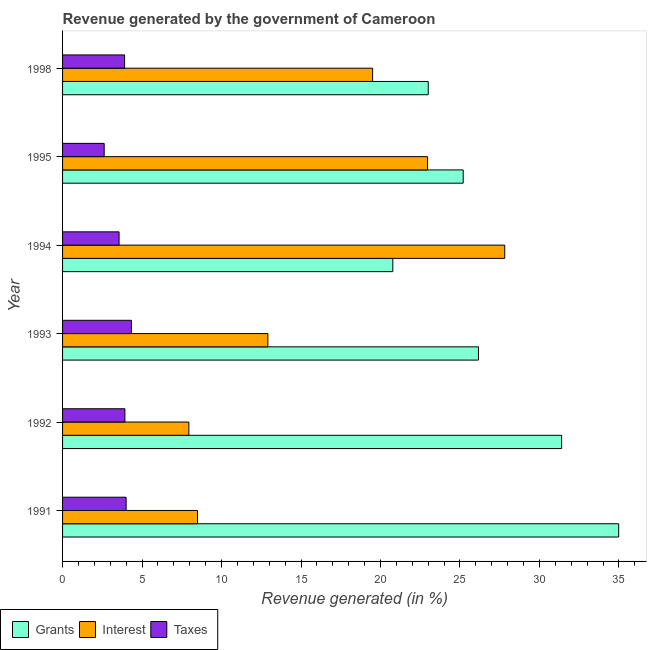How many bars are there on the 1st tick from the bottom?
Make the answer very short. 3. In how many cases, is the number of bars for a given year not equal to the number of legend labels?
Keep it short and to the point. 0. What is the percentage of revenue generated by taxes in 1991?
Provide a succinct answer. 4. Across all years, what is the maximum percentage of revenue generated by grants?
Your response must be concise. 34.99. Across all years, what is the minimum percentage of revenue generated by taxes?
Make the answer very short. 2.62. In which year was the percentage of revenue generated by interest maximum?
Offer a terse response. 1994. In which year was the percentage of revenue generated by taxes minimum?
Make the answer very short. 1995. What is the total percentage of revenue generated by grants in the graph?
Make the answer very short. 161.53. What is the difference between the percentage of revenue generated by grants in 1993 and that in 1994?
Your answer should be very brief. 5.39. What is the difference between the percentage of revenue generated by taxes in 1995 and the percentage of revenue generated by grants in 1993?
Keep it short and to the point. -23.55. What is the average percentage of revenue generated by interest per year?
Your response must be concise. 16.61. In the year 1998, what is the difference between the percentage of revenue generated by grants and percentage of revenue generated by taxes?
Provide a short and direct response. 19.1. In how many years, is the percentage of revenue generated by taxes greater than 12 %?
Keep it short and to the point. 0. What is the ratio of the percentage of revenue generated by grants in 1995 to that in 1998?
Your response must be concise. 1.1. Is the difference between the percentage of revenue generated by grants in 1991 and 1994 greater than the difference between the percentage of revenue generated by taxes in 1991 and 1994?
Make the answer very short. Yes. What is the difference between the highest and the second highest percentage of revenue generated by interest?
Offer a terse response. 4.86. What is the difference between the highest and the lowest percentage of revenue generated by taxes?
Ensure brevity in your answer.  1.71. What does the 3rd bar from the top in 1992 represents?
Offer a terse response. Grants. What does the 3rd bar from the bottom in 1991 represents?
Your answer should be very brief. Taxes. Is it the case that in every year, the sum of the percentage of revenue generated by grants and percentage of revenue generated by interest is greater than the percentage of revenue generated by taxes?
Your answer should be compact. Yes. Are all the bars in the graph horizontal?
Provide a short and direct response. Yes. Does the graph contain any zero values?
Offer a terse response. No. Does the graph contain grids?
Give a very brief answer. No. Where does the legend appear in the graph?
Your answer should be compact. Bottom left. How many legend labels are there?
Your answer should be very brief. 3. What is the title of the graph?
Keep it short and to the point. Revenue generated by the government of Cameroon. Does "Consumption Tax" appear as one of the legend labels in the graph?
Keep it short and to the point. No. What is the label or title of the X-axis?
Ensure brevity in your answer.  Revenue generated (in %). What is the label or title of the Y-axis?
Give a very brief answer. Year. What is the Revenue generated (in %) in Grants in 1991?
Your answer should be very brief. 34.99. What is the Revenue generated (in %) in Interest in 1991?
Ensure brevity in your answer.  8.49. What is the Revenue generated (in %) in Taxes in 1991?
Give a very brief answer. 4. What is the Revenue generated (in %) in Grants in 1992?
Offer a terse response. 31.4. What is the Revenue generated (in %) of Interest in 1992?
Make the answer very short. 7.94. What is the Revenue generated (in %) of Taxes in 1992?
Your answer should be compact. 3.92. What is the Revenue generated (in %) in Grants in 1993?
Provide a short and direct response. 26.16. What is the Revenue generated (in %) of Interest in 1993?
Keep it short and to the point. 12.92. What is the Revenue generated (in %) in Taxes in 1993?
Your response must be concise. 4.33. What is the Revenue generated (in %) of Grants in 1994?
Keep it short and to the point. 20.78. What is the Revenue generated (in %) of Interest in 1994?
Ensure brevity in your answer.  27.82. What is the Revenue generated (in %) of Taxes in 1994?
Give a very brief answer. 3.56. What is the Revenue generated (in %) of Grants in 1995?
Give a very brief answer. 25.2. What is the Revenue generated (in %) of Interest in 1995?
Your answer should be compact. 22.96. What is the Revenue generated (in %) of Taxes in 1995?
Offer a very short reply. 2.62. What is the Revenue generated (in %) in Grants in 1998?
Offer a terse response. 23.01. What is the Revenue generated (in %) in Interest in 1998?
Your answer should be compact. 19.51. What is the Revenue generated (in %) in Taxes in 1998?
Your response must be concise. 3.9. Across all years, what is the maximum Revenue generated (in %) in Grants?
Ensure brevity in your answer.  34.99. Across all years, what is the maximum Revenue generated (in %) in Interest?
Make the answer very short. 27.82. Across all years, what is the maximum Revenue generated (in %) of Taxes?
Offer a terse response. 4.33. Across all years, what is the minimum Revenue generated (in %) in Grants?
Offer a terse response. 20.78. Across all years, what is the minimum Revenue generated (in %) of Interest?
Provide a short and direct response. 7.94. Across all years, what is the minimum Revenue generated (in %) of Taxes?
Provide a succinct answer. 2.62. What is the total Revenue generated (in %) of Grants in the graph?
Make the answer very short. 161.53. What is the total Revenue generated (in %) in Interest in the graph?
Your answer should be compact. 99.63. What is the total Revenue generated (in %) of Taxes in the graph?
Your answer should be compact. 22.33. What is the difference between the Revenue generated (in %) of Grants in 1991 and that in 1992?
Your answer should be compact. 3.59. What is the difference between the Revenue generated (in %) of Interest in 1991 and that in 1992?
Give a very brief answer. 0.54. What is the difference between the Revenue generated (in %) in Taxes in 1991 and that in 1992?
Your answer should be compact. 0.08. What is the difference between the Revenue generated (in %) of Grants in 1991 and that in 1993?
Ensure brevity in your answer.  8.82. What is the difference between the Revenue generated (in %) in Interest in 1991 and that in 1993?
Offer a terse response. -4.43. What is the difference between the Revenue generated (in %) in Taxes in 1991 and that in 1993?
Provide a short and direct response. -0.33. What is the difference between the Revenue generated (in %) of Grants in 1991 and that in 1994?
Offer a very short reply. 14.21. What is the difference between the Revenue generated (in %) of Interest in 1991 and that in 1994?
Provide a succinct answer. -19.33. What is the difference between the Revenue generated (in %) of Taxes in 1991 and that in 1994?
Provide a short and direct response. 0.44. What is the difference between the Revenue generated (in %) in Grants in 1991 and that in 1995?
Give a very brief answer. 9.78. What is the difference between the Revenue generated (in %) in Interest in 1991 and that in 1995?
Your answer should be compact. -14.47. What is the difference between the Revenue generated (in %) in Taxes in 1991 and that in 1995?
Your answer should be very brief. 1.38. What is the difference between the Revenue generated (in %) of Grants in 1991 and that in 1998?
Offer a terse response. 11.98. What is the difference between the Revenue generated (in %) of Interest in 1991 and that in 1998?
Provide a succinct answer. -11.02. What is the difference between the Revenue generated (in %) in Taxes in 1991 and that in 1998?
Give a very brief answer. 0.1. What is the difference between the Revenue generated (in %) of Grants in 1992 and that in 1993?
Offer a very short reply. 5.23. What is the difference between the Revenue generated (in %) in Interest in 1992 and that in 1993?
Make the answer very short. -4.97. What is the difference between the Revenue generated (in %) in Taxes in 1992 and that in 1993?
Your answer should be very brief. -0.41. What is the difference between the Revenue generated (in %) in Grants in 1992 and that in 1994?
Keep it short and to the point. 10.62. What is the difference between the Revenue generated (in %) in Interest in 1992 and that in 1994?
Provide a short and direct response. -19.87. What is the difference between the Revenue generated (in %) of Taxes in 1992 and that in 1994?
Your answer should be very brief. 0.37. What is the difference between the Revenue generated (in %) in Grants in 1992 and that in 1995?
Give a very brief answer. 6.19. What is the difference between the Revenue generated (in %) of Interest in 1992 and that in 1995?
Give a very brief answer. -15.02. What is the difference between the Revenue generated (in %) in Taxes in 1992 and that in 1995?
Your answer should be compact. 1.3. What is the difference between the Revenue generated (in %) of Grants in 1992 and that in 1998?
Provide a short and direct response. 8.39. What is the difference between the Revenue generated (in %) of Interest in 1992 and that in 1998?
Make the answer very short. -11.56. What is the difference between the Revenue generated (in %) in Taxes in 1992 and that in 1998?
Offer a terse response. 0.02. What is the difference between the Revenue generated (in %) of Grants in 1993 and that in 1994?
Ensure brevity in your answer.  5.39. What is the difference between the Revenue generated (in %) in Interest in 1993 and that in 1994?
Your answer should be very brief. -14.9. What is the difference between the Revenue generated (in %) of Taxes in 1993 and that in 1994?
Your answer should be compact. 0.77. What is the difference between the Revenue generated (in %) of Grants in 1993 and that in 1995?
Keep it short and to the point. 0.96. What is the difference between the Revenue generated (in %) of Interest in 1993 and that in 1995?
Your answer should be very brief. -10.05. What is the difference between the Revenue generated (in %) in Taxes in 1993 and that in 1995?
Give a very brief answer. 1.71. What is the difference between the Revenue generated (in %) in Grants in 1993 and that in 1998?
Make the answer very short. 3.16. What is the difference between the Revenue generated (in %) in Interest in 1993 and that in 1998?
Your response must be concise. -6.59. What is the difference between the Revenue generated (in %) in Taxes in 1993 and that in 1998?
Ensure brevity in your answer.  0.43. What is the difference between the Revenue generated (in %) in Grants in 1994 and that in 1995?
Provide a short and direct response. -4.43. What is the difference between the Revenue generated (in %) of Interest in 1994 and that in 1995?
Offer a very short reply. 4.86. What is the difference between the Revenue generated (in %) in Taxes in 1994 and that in 1995?
Give a very brief answer. 0.94. What is the difference between the Revenue generated (in %) in Grants in 1994 and that in 1998?
Offer a terse response. -2.23. What is the difference between the Revenue generated (in %) in Interest in 1994 and that in 1998?
Offer a terse response. 8.31. What is the difference between the Revenue generated (in %) of Taxes in 1994 and that in 1998?
Make the answer very short. -0.35. What is the difference between the Revenue generated (in %) of Grants in 1995 and that in 1998?
Offer a terse response. 2.2. What is the difference between the Revenue generated (in %) in Interest in 1995 and that in 1998?
Ensure brevity in your answer.  3.46. What is the difference between the Revenue generated (in %) of Taxes in 1995 and that in 1998?
Offer a terse response. -1.28. What is the difference between the Revenue generated (in %) in Grants in 1991 and the Revenue generated (in %) in Interest in 1992?
Your answer should be very brief. 27.04. What is the difference between the Revenue generated (in %) of Grants in 1991 and the Revenue generated (in %) of Taxes in 1992?
Keep it short and to the point. 31.06. What is the difference between the Revenue generated (in %) in Interest in 1991 and the Revenue generated (in %) in Taxes in 1992?
Your answer should be compact. 4.57. What is the difference between the Revenue generated (in %) in Grants in 1991 and the Revenue generated (in %) in Interest in 1993?
Ensure brevity in your answer.  22.07. What is the difference between the Revenue generated (in %) in Grants in 1991 and the Revenue generated (in %) in Taxes in 1993?
Keep it short and to the point. 30.66. What is the difference between the Revenue generated (in %) of Interest in 1991 and the Revenue generated (in %) of Taxes in 1993?
Your response must be concise. 4.16. What is the difference between the Revenue generated (in %) of Grants in 1991 and the Revenue generated (in %) of Interest in 1994?
Offer a terse response. 7.17. What is the difference between the Revenue generated (in %) of Grants in 1991 and the Revenue generated (in %) of Taxes in 1994?
Offer a very short reply. 31.43. What is the difference between the Revenue generated (in %) of Interest in 1991 and the Revenue generated (in %) of Taxes in 1994?
Provide a short and direct response. 4.93. What is the difference between the Revenue generated (in %) in Grants in 1991 and the Revenue generated (in %) in Interest in 1995?
Make the answer very short. 12.02. What is the difference between the Revenue generated (in %) of Grants in 1991 and the Revenue generated (in %) of Taxes in 1995?
Provide a succinct answer. 32.37. What is the difference between the Revenue generated (in %) in Interest in 1991 and the Revenue generated (in %) in Taxes in 1995?
Ensure brevity in your answer.  5.87. What is the difference between the Revenue generated (in %) in Grants in 1991 and the Revenue generated (in %) in Interest in 1998?
Give a very brief answer. 15.48. What is the difference between the Revenue generated (in %) of Grants in 1991 and the Revenue generated (in %) of Taxes in 1998?
Your answer should be very brief. 31.08. What is the difference between the Revenue generated (in %) in Interest in 1991 and the Revenue generated (in %) in Taxes in 1998?
Give a very brief answer. 4.59. What is the difference between the Revenue generated (in %) of Grants in 1992 and the Revenue generated (in %) of Interest in 1993?
Ensure brevity in your answer.  18.48. What is the difference between the Revenue generated (in %) of Grants in 1992 and the Revenue generated (in %) of Taxes in 1993?
Your response must be concise. 27.07. What is the difference between the Revenue generated (in %) in Interest in 1992 and the Revenue generated (in %) in Taxes in 1993?
Keep it short and to the point. 3.62. What is the difference between the Revenue generated (in %) of Grants in 1992 and the Revenue generated (in %) of Interest in 1994?
Ensure brevity in your answer.  3.58. What is the difference between the Revenue generated (in %) of Grants in 1992 and the Revenue generated (in %) of Taxes in 1994?
Your response must be concise. 27.84. What is the difference between the Revenue generated (in %) in Interest in 1992 and the Revenue generated (in %) in Taxes in 1994?
Make the answer very short. 4.39. What is the difference between the Revenue generated (in %) in Grants in 1992 and the Revenue generated (in %) in Interest in 1995?
Your answer should be compact. 8.43. What is the difference between the Revenue generated (in %) in Grants in 1992 and the Revenue generated (in %) in Taxes in 1995?
Provide a short and direct response. 28.78. What is the difference between the Revenue generated (in %) in Interest in 1992 and the Revenue generated (in %) in Taxes in 1995?
Keep it short and to the point. 5.33. What is the difference between the Revenue generated (in %) in Grants in 1992 and the Revenue generated (in %) in Interest in 1998?
Your response must be concise. 11.89. What is the difference between the Revenue generated (in %) of Grants in 1992 and the Revenue generated (in %) of Taxes in 1998?
Make the answer very short. 27.49. What is the difference between the Revenue generated (in %) in Interest in 1992 and the Revenue generated (in %) in Taxes in 1998?
Provide a succinct answer. 4.04. What is the difference between the Revenue generated (in %) of Grants in 1993 and the Revenue generated (in %) of Interest in 1994?
Ensure brevity in your answer.  -1.65. What is the difference between the Revenue generated (in %) of Grants in 1993 and the Revenue generated (in %) of Taxes in 1994?
Keep it short and to the point. 22.61. What is the difference between the Revenue generated (in %) in Interest in 1993 and the Revenue generated (in %) in Taxes in 1994?
Offer a terse response. 9.36. What is the difference between the Revenue generated (in %) of Grants in 1993 and the Revenue generated (in %) of Interest in 1995?
Make the answer very short. 3.2. What is the difference between the Revenue generated (in %) in Grants in 1993 and the Revenue generated (in %) in Taxes in 1995?
Provide a short and direct response. 23.55. What is the difference between the Revenue generated (in %) of Interest in 1993 and the Revenue generated (in %) of Taxes in 1995?
Provide a succinct answer. 10.3. What is the difference between the Revenue generated (in %) of Grants in 1993 and the Revenue generated (in %) of Interest in 1998?
Your answer should be compact. 6.66. What is the difference between the Revenue generated (in %) in Grants in 1993 and the Revenue generated (in %) in Taxes in 1998?
Give a very brief answer. 22.26. What is the difference between the Revenue generated (in %) of Interest in 1993 and the Revenue generated (in %) of Taxes in 1998?
Offer a terse response. 9.01. What is the difference between the Revenue generated (in %) of Grants in 1994 and the Revenue generated (in %) of Interest in 1995?
Ensure brevity in your answer.  -2.19. What is the difference between the Revenue generated (in %) in Grants in 1994 and the Revenue generated (in %) in Taxes in 1995?
Keep it short and to the point. 18.16. What is the difference between the Revenue generated (in %) in Interest in 1994 and the Revenue generated (in %) in Taxes in 1995?
Ensure brevity in your answer.  25.2. What is the difference between the Revenue generated (in %) of Grants in 1994 and the Revenue generated (in %) of Interest in 1998?
Keep it short and to the point. 1.27. What is the difference between the Revenue generated (in %) in Grants in 1994 and the Revenue generated (in %) in Taxes in 1998?
Provide a succinct answer. 16.87. What is the difference between the Revenue generated (in %) of Interest in 1994 and the Revenue generated (in %) of Taxes in 1998?
Your answer should be very brief. 23.91. What is the difference between the Revenue generated (in %) in Grants in 1995 and the Revenue generated (in %) in Interest in 1998?
Ensure brevity in your answer.  5.7. What is the difference between the Revenue generated (in %) in Grants in 1995 and the Revenue generated (in %) in Taxes in 1998?
Provide a short and direct response. 21.3. What is the difference between the Revenue generated (in %) of Interest in 1995 and the Revenue generated (in %) of Taxes in 1998?
Offer a terse response. 19.06. What is the average Revenue generated (in %) of Grants per year?
Keep it short and to the point. 26.92. What is the average Revenue generated (in %) in Interest per year?
Give a very brief answer. 16.61. What is the average Revenue generated (in %) in Taxes per year?
Your response must be concise. 3.72. In the year 1991, what is the difference between the Revenue generated (in %) of Grants and Revenue generated (in %) of Interest?
Provide a succinct answer. 26.5. In the year 1991, what is the difference between the Revenue generated (in %) in Grants and Revenue generated (in %) in Taxes?
Give a very brief answer. 30.99. In the year 1991, what is the difference between the Revenue generated (in %) in Interest and Revenue generated (in %) in Taxes?
Ensure brevity in your answer.  4.49. In the year 1992, what is the difference between the Revenue generated (in %) of Grants and Revenue generated (in %) of Interest?
Offer a very short reply. 23.45. In the year 1992, what is the difference between the Revenue generated (in %) in Grants and Revenue generated (in %) in Taxes?
Offer a very short reply. 27.47. In the year 1992, what is the difference between the Revenue generated (in %) in Interest and Revenue generated (in %) in Taxes?
Give a very brief answer. 4.02. In the year 1993, what is the difference between the Revenue generated (in %) in Grants and Revenue generated (in %) in Interest?
Provide a short and direct response. 13.25. In the year 1993, what is the difference between the Revenue generated (in %) in Grants and Revenue generated (in %) in Taxes?
Offer a very short reply. 21.83. In the year 1993, what is the difference between the Revenue generated (in %) in Interest and Revenue generated (in %) in Taxes?
Offer a very short reply. 8.59. In the year 1994, what is the difference between the Revenue generated (in %) of Grants and Revenue generated (in %) of Interest?
Provide a short and direct response. -7.04. In the year 1994, what is the difference between the Revenue generated (in %) of Grants and Revenue generated (in %) of Taxes?
Provide a short and direct response. 17.22. In the year 1994, what is the difference between the Revenue generated (in %) in Interest and Revenue generated (in %) in Taxes?
Provide a succinct answer. 24.26. In the year 1995, what is the difference between the Revenue generated (in %) of Grants and Revenue generated (in %) of Interest?
Give a very brief answer. 2.24. In the year 1995, what is the difference between the Revenue generated (in %) of Grants and Revenue generated (in %) of Taxes?
Offer a very short reply. 22.59. In the year 1995, what is the difference between the Revenue generated (in %) of Interest and Revenue generated (in %) of Taxes?
Ensure brevity in your answer.  20.34. In the year 1998, what is the difference between the Revenue generated (in %) of Grants and Revenue generated (in %) of Interest?
Offer a terse response. 3.5. In the year 1998, what is the difference between the Revenue generated (in %) in Grants and Revenue generated (in %) in Taxes?
Your answer should be compact. 19.1. In the year 1998, what is the difference between the Revenue generated (in %) in Interest and Revenue generated (in %) in Taxes?
Your response must be concise. 15.6. What is the ratio of the Revenue generated (in %) in Grants in 1991 to that in 1992?
Provide a succinct answer. 1.11. What is the ratio of the Revenue generated (in %) of Interest in 1991 to that in 1992?
Give a very brief answer. 1.07. What is the ratio of the Revenue generated (in %) in Taxes in 1991 to that in 1992?
Offer a terse response. 1.02. What is the ratio of the Revenue generated (in %) in Grants in 1991 to that in 1993?
Make the answer very short. 1.34. What is the ratio of the Revenue generated (in %) in Interest in 1991 to that in 1993?
Your answer should be compact. 0.66. What is the ratio of the Revenue generated (in %) of Taxes in 1991 to that in 1993?
Make the answer very short. 0.92. What is the ratio of the Revenue generated (in %) of Grants in 1991 to that in 1994?
Your answer should be compact. 1.68. What is the ratio of the Revenue generated (in %) in Interest in 1991 to that in 1994?
Your response must be concise. 0.31. What is the ratio of the Revenue generated (in %) in Taxes in 1991 to that in 1994?
Your response must be concise. 1.12. What is the ratio of the Revenue generated (in %) in Grants in 1991 to that in 1995?
Keep it short and to the point. 1.39. What is the ratio of the Revenue generated (in %) in Interest in 1991 to that in 1995?
Your answer should be compact. 0.37. What is the ratio of the Revenue generated (in %) in Taxes in 1991 to that in 1995?
Keep it short and to the point. 1.53. What is the ratio of the Revenue generated (in %) in Grants in 1991 to that in 1998?
Offer a very short reply. 1.52. What is the ratio of the Revenue generated (in %) of Interest in 1991 to that in 1998?
Your response must be concise. 0.44. What is the ratio of the Revenue generated (in %) of Taxes in 1991 to that in 1998?
Provide a succinct answer. 1.02. What is the ratio of the Revenue generated (in %) in Grants in 1992 to that in 1993?
Your response must be concise. 1.2. What is the ratio of the Revenue generated (in %) in Interest in 1992 to that in 1993?
Provide a succinct answer. 0.62. What is the ratio of the Revenue generated (in %) of Taxes in 1992 to that in 1993?
Your answer should be compact. 0.91. What is the ratio of the Revenue generated (in %) of Grants in 1992 to that in 1994?
Ensure brevity in your answer.  1.51. What is the ratio of the Revenue generated (in %) of Interest in 1992 to that in 1994?
Keep it short and to the point. 0.29. What is the ratio of the Revenue generated (in %) of Taxes in 1992 to that in 1994?
Make the answer very short. 1.1. What is the ratio of the Revenue generated (in %) of Grants in 1992 to that in 1995?
Your answer should be compact. 1.25. What is the ratio of the Revenue generated (in %) of Interest in 1992 to that in 1995?
Provide a succinct answer. 0.35. What is the ratio of the Revenue generated (in %) of Taxes in 1992 to that in 1995?
Your response must be concise. 1.5. What is the ratio of the Revenue generated (in %) in Grants in 1992 to that in 1998?
Ensure brevity in your answer.  1.36. What is the ratio of the Revenue generated (in %) of Interest in 1992 to that in 1998?
Offer a terse response. 0.41. What is the ratio of the Revenue generated (in %) in Taxes in 1992 to that in 1998?
Keep it short and to the point. 1.01. What is the ratio of the Revenue generated (in %) of Grants in 1993 to that in 1994?
Offer a terse response. 1.26. What is the ratio of the Revenue generated (in %) in Interest in 1993 to that in 1994?
Your answer should be compact. 0.46. What is the ratio of the Revenue generated (in %) in Taxes in 1993 to that in 1994?
Your response must be concise. 1.22. What is the ratio of the Revenue generated (in %) in Grants in 1993 to that in 1995?
Keep it short and to the point. 1.04. What is the ratio of the Revenue generated (in %) in Interest in 1993 to that in 1995?
Provide a short and direct response. 0.56. What is the ratio of the Revenue generated (in %) of Taxes in 1993 to that in 1995?
Provide a succinct answer. 1.65. What is the ratio of the Revenue generated (in %) of Grants in 1993 to that in 1998?
Provide a short and direct response. 1.14. What is the ratio of the Revenue generated (in %) of Interest in 1993 to that in 1998?
Offer a terse response. 0.66. What is the ratio of the Revenue generated (in %) of Taxes in 1993 to that in 1998?
Ensure brevity in your answer.  1.11. What is the ratio of the Revenue generated (in %) in Grants in 1994 to that in 1995?
Ensure brevity in your answer.  0.82. What is the ratio of the Revenue generated (in %) of Interest in 1994 to that in 1995?
Ensure brevity in your answer.  1.21. What is the ratio of the Revenue generated (in %) in Taxes in 1994 to that in 1995?
Give a very brief answer. 1.36. What is the ratio of the Revenue generated (in %) in Grants in 1994 to that in 1998?
Your response must be concise. 0.9. What is the ratio of the Revenue generated (in %) of Interest in 1994 to that in 1998?
Your response must be concise. 1.43. What is the ratio of the Revenue generated (in %) of Taxes in 1994 to that in 1998?
Your answer should be compact. 0.91. What is the ratio of the Revenue generated (in %) of Grants in 1995 to that in 1998?
Your answer should be very brief. 1.1. What is the ratio of the Revenue generated (in %) of Interest in 1995 to that in 1998?
Keep it short and to the point. 1.18. What is the ratio of the Revenue generated (in %) in Taxes in 1995 to that in 1998?
Your response must be concise. 0.67. What is the difference between the highest and the second highest Revenue generated (in %) of Grants?
Offer a terse response. 3.59. What is the difference between the highest and the second highest Revenue generated (in %) of Interest?
Ensure brevity in your answer.  4.86. What is the difference between the highest and the second highest Revenue generated (in %) in Taxes?
Provide a succinct answer. 0.33. What is the difference between the highest and the lowest Revenue generated (in %) in Grants?
Your response must be concise. 14.21. What is the difference between the highest and the lowest Revenue generated (in %) of Interest?
Provide a succinct answer. 19.87. What is the difference between the highest and the lowest Revenue generated (in %) of Taxes?
Provide a succinct answer. 1.71. 